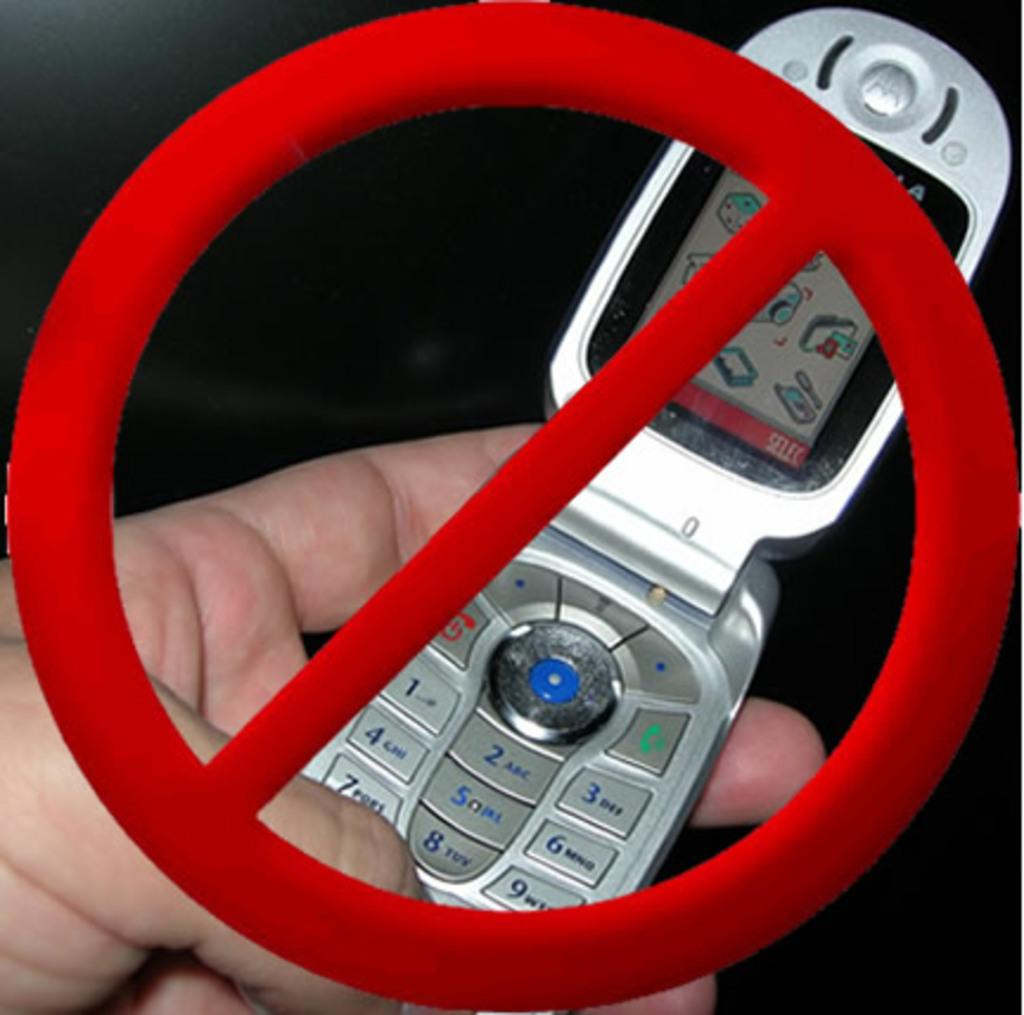What is the main object in the image? There is a symbol of a sign in the image. What is the person in the image doing? A person is holding a mobile in the image. How would you describe the overall lighting in the image? The background of the image is dark. What type of toy can be seen in the person's throat in the image? There is no toy or reference to a throat in the image; it only features a symbol of a sign and a person holding a mobile. 